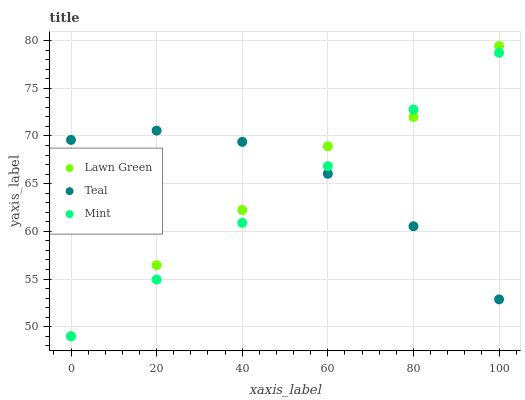Does Mint have the minimum area under the curve?
Answer yes or no. Yes. Does Teal have the maximum area under the curve?
Answer yes or no. Yes. Does Teal have the minimum area under the curve?
Answer yes or no. No. Does Mint have the maximum area under the curve?
Answer yes or no. No. Is Mint the smoothest?
Answer yes or no. Yes. Is Lawn Green the roughest?
Answer yes or no. Yes. Is Teal the smoothest?
Answer yes or no. No. Is Teal the roughest?
Answer yes or no. No. Does Lawn Green have the lowest value?
Answer yes or no. Yes. Does Teal have the lowest value?
Answer yes or no. No. Does Lawn Green have the highest value?
Answer yes or no. Yes. Does Mint have the highest value?
Answer yes or no. No. Does Lawn Green intersect Mint?
Answer yes or no. Yes. Is Lawn Green less than Mint?
Answer yes or no. No. Is Lawn Green greater than Mint?
Answer yes or no. No. 